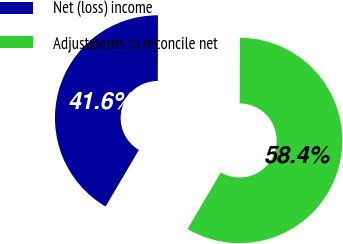Convert chart. <chart><loc_0><loc_0><loc_500><loc_500><pie_chart><fcel>Net (loss) income<fcel>Adjustments to reconcile net<nl><fcel>41.59%<fcel>58.41%<nl></chart> 